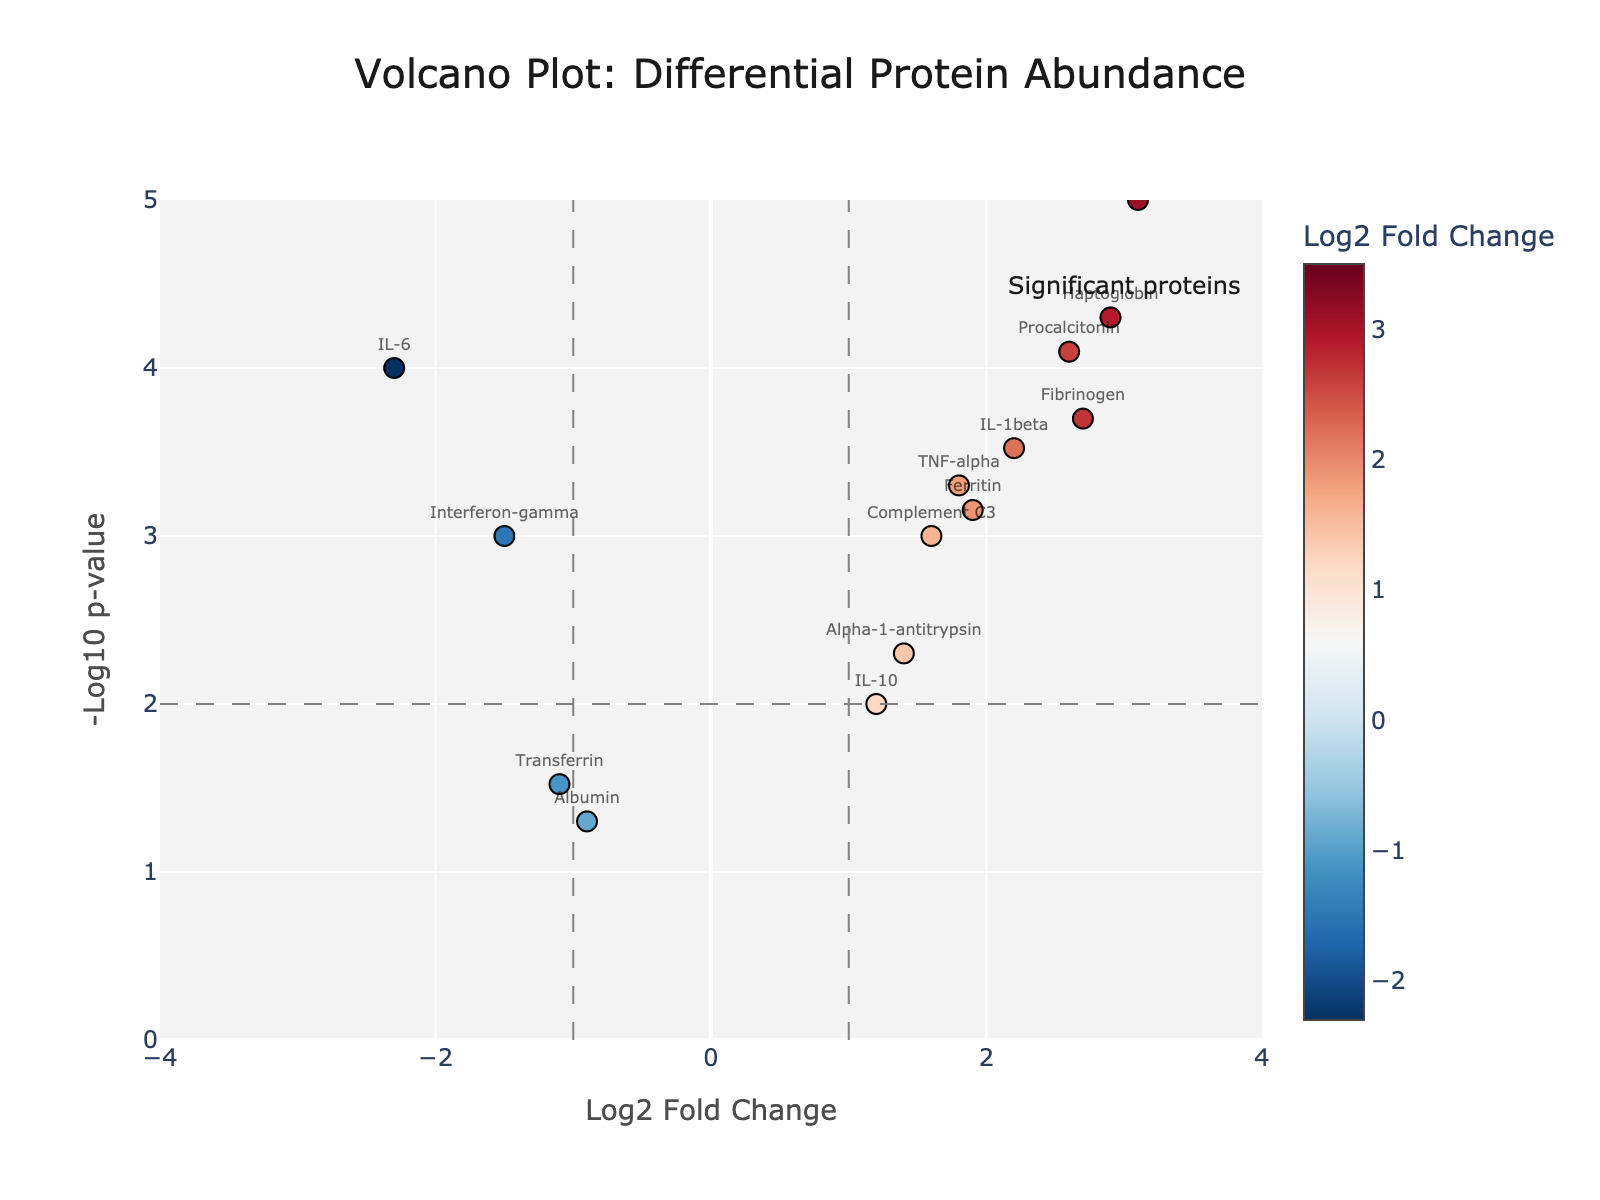What is the title of the figure? The title is given at the top of the figure and reads "Volcano Plot: Differential Protein Abundance".
Answer: Volcano Plot: Differential Protein Abundance What are the units on the x-axis? The x-axis units are "Log2 Fold Change". This indicates that it shows the logarithm to the base 2 of the fold change.
Answer: Log2 Fold Change How many proteins are significantly upregulated with a log2 fold change greater than 2? We identify proteins with a positive log2 fold change greater than 2 and a high -log10 p-value. These are: C-reactive protein, Fibrinogen, Haptoglobin, Serum amyloid A, IL-1beta, Procalcitonin.
Answer: 6 Which protein has the highest -log10 p-value? By examining the y-axis values which represent -log10 p-values, Serum amyloid A stands out as having the highest value.
Answer: Serum amyloid A How many proteins have a log2 fold change less than -1 and p-value less than 0.05? We look at the data points to find proteins with a log2 fold change less than -1 and a -log10 p-value greater than 1.3 (since -log10(0.05) ≈ 1.3). The proteins are IL-6 and Interferon-gamma.
Answer: 2 What does a point with a large positive log2 fold change and high -log10 p-value indicate? A large positive log2 fold change indicates that the protein is more abundant in diseased tissue compared to healthy tissue, and a high -log10 p-value indicates strong statistical significance.
Answer: High abundance in diseased tissue and strong significance Which protein shows the highest fold change in diseased tissue? The highest log2 fold change on the positive side of the x-axis corresponds to Serum amyloid A.
Answer: Serum amyloid A What is the p-value of IL-10 and how is it represented in the figure? IL-10 has a p-value of 0.01. In the Volcano Plot, this corresponds to approximately -log10(0.01) which is 2.
Answer: 0.01, approximately -2 on y-axis Compare the log2 fold change values of IL-6 and TNF-alpha. Which is higher? IL-6 has a log2 fold change of -2.3, while TNF-alpha has 1.8. Thus, TNF-alpha is higher.
Answer: TNF-alpha What does the color scale represent in the plot and how is it applied to the data points? The color scale represents the log2 fold change values. Data points are colored according to these values, with a color gradient showing the variation.
Answer: Log2 Fold Change 